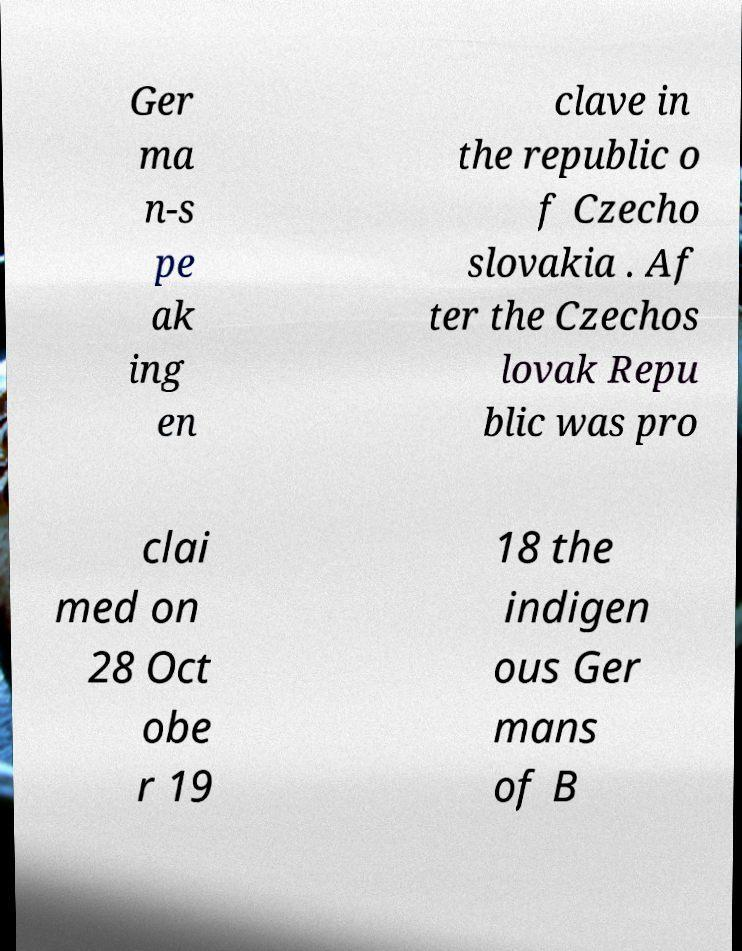Please identify and transcribe the text found in this image. Ger ma n-s pe ak ing en clave in the republic o f Czecho slovakia . Af ter the Czechos lovak Repu blic was pro clai med on 28 Oct obe r 19 18 the indigen ous Ger mans of B 